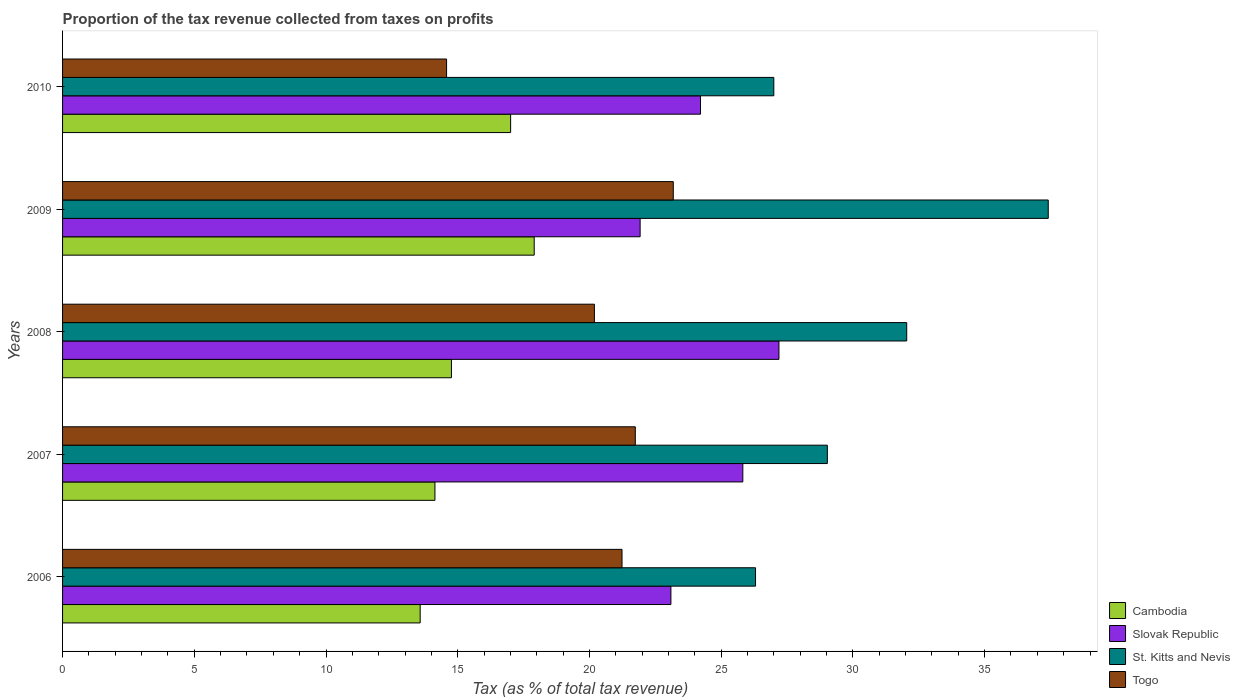How many groups of bars are there?
Your response must be concise. 5. Are the number of bars per tick equal to the number of legend labels?
Your answer should be compact. Yes. Are the number of bars on each tick of the Y-axis equal?
Make the answer very short. Yes. How many bars are there on the 5th tick from the top?
Your response must be concise. 4. How many bars are there on the 2nd tick from the bottom?
Ensure brevity in your answer.  4. In how many cases, is the number of bars for a given year not equal to the number of legend labels?
Make the answer very short. 0. What is the proportion of the tax revenue collected in Cambodia in 2007?
Give a very brief answer. 14.13. Across all years, what is the maximum proportion of the tax revenue collected in Cambodia?
Your response must be concise. 17.9. Across all years, what is the minimum proportion of the tax revenue collected in Togo?
Give a very brief answer. 14.58. In which year was the proportion of the tax revenue collected in Cambodia minimum?
Offer a very short reply. 2006. What is the total proportion of the tax revenue collected in Togo in the graph?
Your answer should be very brief. 100.92. What is the difference between the proportion of the tax revenue collected in Cambodia in 2007 and that in 2009?
Your answer should be compact. -3.77. What is the difference between the proportion of the tax revenue collected in Cambodia in 2010 and the proportion of the tax revenue collected in Slovak Republic in 2007?
Ensure brevity in your answer.  -8.81. What is the average proportion of the tax revenue collected in Togo per year?
Offer a very short reply. 20.18. In the year 2007, what is the difference between the proportion of the tax revenue collected in Cambodia and proportion of the tax revenue collected in Slovak Republic?
Give a very brief answer. -11.69. In how many years, is the proportion of the tax revenue collected in Slovak Republic greater than 22 %?
Provide a succinct answer. 4. What is the ratio of the proportion of the tax revenue collected in Cambodia in 2006 to that in 2008?
Your answer should be compact. 0.92. What is the difference between the highest and the second highest proportion of the tax revenue collected in Cambodia?
Your response must be concise. 0.9. What is the difference between the highest and the lowest proportion of the tax revenue collected in Slovak Republic?
Offer a terse response. 5.27. In how many years, is the proportion of the tax revenue collected in St. Kitts and Nevis greater than the average proportion of the tax revenue collected in St. Kitts and Nevis taken over all years?
Give a very brief answer. 2. Is the sum of the proportion of the tax revenue collected in St. Kitts and Nevis in 2007 and 2008 greater than the maximum proportion of the tax revenue collected in Togo across all years?
Provide a short and direct response. Yes. What does the 3rd bar from the top in 2006 represents?
Your response must be concise. Slovak Republic. What does the 2nd bar from the bottom in 2010 represents?
Give a very brief answer. Slovak Republic. Is it the case that in every year, the sum of the proportion of the tax revenue collected in Slovak Republic and proportion of the tax revenue collected in Togo is greater than the proportion of the tax revenue collected in Cambodia?
Offer a terse response. Yes. How many bars are there?
Ensure brevity in your answer.  20. Are all the bars in the graph horizontal?
Your answer should be compact. Yes. How many years are there in the graph?
Give a very brief answer. 5. Are the values on the major ticks of X-axis written in scientific E-notation?
Offer a terse response. No. Does the graph contain grids?
Offer a very short reply. No. How many legend labels are there?
Your answer should be very brief. 4. What is the title of the graph?
Your answer should be very brief. Proportion of the tax revenue collected from taxes on profits. What is the label or title of the X-axis?
Provide a short and direct response. Tax (as % of total tax revenue). What is the label or title of the Y-axis?
Offer a terse response. Years. What is the Tax (as % of total tax revenue) in Cambodia in 2006?
Your response must be concise. 13.57. What is the Tax (as % of total tax revenue) of Slovak Republic in 2006?
Your response must be concise. 23.09. What is the Tax (as % of total tax revenue) of St. Kitts and Nevis in 2006?
Offer a very short reply. 26.3. What is the Tax (as % of total tax revenue) in Togo in 2006?
Offer a terse response. 21.24. What is the Tax (as % of total tax revenue) in Cambodia in 2007?
Your response must be concise. 14.13. What is the Tax (as % of total tax revenue) of Slovak Republic in 2007?
Keep it short and to the point. 25.82. What is the Tax (as % of total tax revenue) in St. Kitts and Nevis in 2007?
Provide a short and direct response. 29.03. What is the Tax (as % of total tax revenue) in Togo in 2007?
Make the answer very short. 21.74. What is the Tax (as % of total tax revenue) in Cambodia in 2008?
Keep it short and to the point. 14.76. What is the Tax (as % of total tax revenue) in Slovak Republic in 2008?
Your response must be concise. 27.19. What is the Tax (as % of total tax revenue) of St. Kitts and Nevis in 2008?
Provide a succinct answer. 32.04. What is the Tax (as % of total tax revenue) of Togo in 2008?
Offer a very short reply. 20.19. What is the Tax (as % of total tax revenue) in Cambodia in 2009?
Your answer should be very brief. 17.9. What is the Tax (as % of total tax revenue) of Slovak Republic in 2009?
Offer a terse response. 21.92. What is the Tax (as % of total tax revenue) in St. Kitts and Nevis in 2009?
Your response must be concise. 37.41. What is the Tax (as % of total tax revenue) of Togo in 2009?
Your answer should be compact. 23.18. What is the Tax (as % of total tax revenue) in Cambodia in 2010?
Give a very brief answer. 17.01. What is the Tax (as % of total tax revenue) of Slovak Republic in 2010?
Provide a short and direct response. 24.21. What is the Tax (as % of total tax revenue) in St. Kitts and Nevis in 2010?
Provide a short and direct response. 27. What is the Tax (as % of total tax revenue) of Togo in 2010?
Your response must be concise. 14.58. Across all years, what is the maximum Tax (as % of total tax revenue) of Cambodia?
Ensure brevity in your answer.  17.9. Across all years, what is the maximum Tax (as % of total tax revenue) in Slovak Republic?
Give a very brief answer. 27.19. Across all years, what is the maximum Tax (as % of total tax revenue) in St. Kitts and Nevis?
Offer a very short reply. 37.41. Across all years, what is the maximum Tax (as % of total tax revenue) in Togo?
Offer a very short reply. 23.18. Across all years, what is the minimum Tax (as % of total tax revenue) in Cambodia?
Offer a terse response. 13.57. Across all years, what is the minimum Tax (as % of total tax revenue) of Slovak Republic?
Ensure brevity in your answer.  21.92. Across all years, what is the minimum Tax (as % of total tax revenue) in St. Kitts and Nevis?
Provide a succinct answer. 26.3. Across all years, what is the minimum Tax (as % of total tax revenue) of Togo?
Provide a succinct answer. 14.58. What is the total Tax (as % of total tax revenue) of Cambodia in the graph?
Provide a succinct answer. 77.38. What is the total Tax (as % of total tax revenue) of Slovak Republic in the graph?
Your response must be concise. 122.24. What is the total Tax (as % of total tax revenue) in St. Kitts and Nevis in the graph?
Give a very brief answer. 151.79. What is the total Tax (as % of total tax revenue) of Togo in the graph?
Give a very brief answer. 100.92. What is the difference between the Tax (as % of total tax revenue) of Cambodia in 2006 and that in 2007?
Offer a terse response. -0.56. What is the difference between the Tax (as % of total tax revenue) in Slovak Republic in 2006 and that in 2007?
Offer a terse response. -2.73. What is the difference between the Tax (as % of total tax revenue) of St. Kitts and Nevis in 2006 and that in 2007?
Give a very brief answer. -2.73. What is the difference between the Tax (as % of total tax revenue) in Togo in 2006 and that in 2007?
Ensure brevity in your answer.  -0.5. What is the difference between the Tax (as % of total tax revenue) of Cambodia in 2006 and that in 2008?
Make the answer very short. -1.19. What is the difference between the Tax (as % of total tax revenue) of Slovak Republic in 2006 and that in 2008?
Your answer should be compact. -4.1. What is the difference between the Tax (as % of total tax revenue) of St. Kitts and Nevis in 2006 and that in 2008?
Ensure brevity in your answer.  -5.74. What is the difference between the Tax (as % of total tax revenue) of Togo in 2006 and that in 2008?
Provide a succinct answer. 1.05. What is the difference between the Tax (as % of total tax revenue) of Cambodia in 2006 and that in 2009?
Provide a short and direct response. -4.33. What is the difference between the Tax (as % of total tax revenue) of Slovak Republic in 2006 and that in 2009?
Ensure brevity in your answer.  1.17. What is the difference between the Tax (as % of total tax revenue) of St. Kitts and Nevis in 2006 and that in 2009?
Make the answer very short. -11.11. What is the difference between the Tax (as % of total tax revenue) in Togo in 2006 and that in 2009?
Your response must be concise. -1.95. What is the difference between the Tax (as % of total tax revenue) in Cambodia in 2006 and that in 2010?
Provide a succinct answer. -3.43. What is the difference between the Tax (as % of total tax revenue) in Slovak Republic in 2006 and that in 2010?
Provide a short and direct response. -1.12. What is the difference between the Tax (as % of total tax revenue) in St. Kitts and Nevis in 2006 and that in 2010?
Your answer should be compact. -0.69. What is the difference between the Tax (as % of total tax revenue) in Togo in 2006 and that in 2010?
Offer a terse response. 6.66. What is the difference between the Tax (as % of total tax revenue) of Cambodia in 2007 and that in 2008?
Your answer should be very brief. -0.63. What is the difference between the Tax (as % of total tax revenue) of Slovak Republic in 2007 and that in 2008?
Your answer should be very brief. -1.37. What is the difference between the Tax (as % of total tax revenue) in St. Kitts and Nevis in 2007 and that in 2008?
Provide a short and direct response. -3.01. What is the difference between the Tax (as % of total tax revenue) in Togo in 2007 and that in 2008?
Ensure brevity in your answer.  1.55. What is the difference between the Tax (as % of total tax revenue) in Cambodia in 2007 and that in 2009?
Offer a very short reply. -3.77. What is the difference between the Tax (as % of total tax revenue) of Slovak Republic in 2007 and that in 2009?
Ensure brevity in your answer.  3.9. What is the difference between the Tax (as % of total tax revenue) in St. Kitts and Nevis in 2007 and that in 2009?
Your response must be concise. -8.39. What is the difference between the Tax (as % of total tax revenue) of Togo in 2007 and that in 2009?
Keep it short and to the point. -1.44. What is the difference between the Tax (as % of total tax revenue) in Cambodia in 2007 and that in 2010?
Keep it short and to the point. -2.87. What is the difference between the Tax (as % of total tax revenue) of Slovak Republic in 2007 and that in 2010?
Your answer should be compact. 1.61. What is the difference between the Tax (as % of total tax revenue) of St. Kitts and Nevis in 2007 and that in 2010?
Make the answer very short. 2.03. What is the difference between the Tax (as % of total tax revenue) of Togo in 2007 and that in 2010?
Offer a very short reply. 7.16. What is the difference between the Tax (as % of total tax revenue) of Cambodia in 2008 and that in 2009?
Provide a succinct answer. -3.14. What is the difference between the Tax (as % of total tax revenue) of Slovak Republic in 2008 and that in 2009?
Provide a succinct answer. 5.27. What is the difference between the Tax (as % of total tax revenue) in St. Kitts and Nevis in 2008 and that in 2009?
Provide a succinct answer. -5.37. What is the difference between the Tax (as % of total tax revenue) of Togo in 2008 and that in 2009?
Your answer should be very brief. -2.99. What is the difference between the Tax (as % of total tax revenue) of Cambodia in 2008 and that in 2010?
Keep it short and to the point. -2.25. What is the difference between the Tax (as % of total tax revenue) of Slovak Republic in 2008 and that in 2010?
Give a very brief answer. 2.98. What is the difference between the Tax (as % of total tax revenue) of St. Kitts and Nevis in 2008 and that in 2010?
Keep it short and to the point. 5.04. What is the difference between the Tax (as % of total tax revenue) of Togo in 2008 and that in 2010?
Provide a short and direct response. 5.61. What is the difference between the Tax (as % of total tax revenue) in Cambodia in 2009 and that in 2010?
Provide a short and direct response. 0.9. What is the difference between the Tax (as % of total tax revenue) in Slovak Republic in 2009 and that in 2010?
Provide a short and direct response. -2.29. What is the difference between the Tax (as % of total tax revenue) of St. Kitts and Nevis in 2009 and that in 2010?
Your answer should be very brief. 10.42. What is the difference between the Tax (as % of total tax revenue) in Togo in 2009 and that in 2010?
Offer a terse response. 8.61. What is the difference between the Tax (as % of total tax revenue) of Cambodia in 2006 and the Tax (as % of total tax revenue) of Slovak Republic in 2007?
Ensure brevity in your answer.  -12.25. What is the difference between the Tax (as % of total tax revenue) of Cambodia in 2006 and the Tax (as % of total tax revenue) of St. Kitts and Nevis in 2007?
Give a very brief answer. -15.46. What is the difference between the Tax (as % of total tax revenue) of Cambodia in 2006 and the Tax (as % of total tax revenue) of Togo in 2007?
Make the answer very short. -8.17. What is the difference between the Tax (as % of total tax revenue) of Slovak Republic in 2006 and the Tax (as % of total tax revenue) of St. Kitts and Nevis in 2007?
Ensure brevity in your answer.  -5.94. What is the difference between the Tax (as % of total tax revenue) of Slovak Republic in 2006 and the Tax (as % of total tax revenue) of Togo in 2007?
Offer a terse response. 1.35. What is the difference between the Tax (as % of total tax revenue) in St. Kitts and Nevis in 2006 and the Tax (as % of total tax revenue) in Togo in 2007?
Offer a terse response. 4.56. What is the difference between the Tax (as % of total tax revenue) of Cambodia in 2006 and the Tax (as % of total tax revenue) of Slovak Republic in 2008?
Ensure brevity in your answer.  -13.62. What is the difference between the Tax (as % of total tax revenue) of Cambodia in 2006 and the Tax (as % of total tax revenue) of St. Kitts and Nevis in 2008?
Your answer should be compact. -18.47. What is the difference between the Tax (as % of total tax revenue) of Cambodia in 2006 and the Tax (as % of total tax revenue) of Togo in 2008?
Your response must be concise. -6.61. What is the difference between the Tax (as % of total tax revenue) of Slovak Republic in 2006 and the Tax (as % of total tax revenue) of St. Kitts and Nevis in 2008?
Your answer should be very brief. -8.95. What is the difference between the Tax (as % of total tax revenue) in Slovak Republic in 2006 and the Tax (as % of total tax revenue) in Togo in 2008?
Offer a very short reply. 2.9. What is the difference between the Tax (as % of total tax revenue) of St. Kitts and Nevis in 2006 and the Tax (as % of total tax revenue) of Togo in 2008?
Your answer should be very brief. 6.12. What is the difference between the Tax (as % of total tax revenue) in Cambodia in 2006 and the Tax (as % of total tax revenue) in Slovak Republic in 2009?
Your answer should be very brief. -8.35. What is the difference between the Tax (as % of total tax revenue) of Cambodia in 2006 and the Tax (as % of total tax revenue) of St. Kitts and Nevis in 2009?
Make the answer very short. -23.84. What is the difference between the Tax (as % of total tax revenue) of Cambodia in 2006 and the Tax (as % of total tax revenue) of Togo in 2009?
Give a very brief answer. -9.61. What is the difference between the Tax (as % of total tax revenue) in Slovak Republic in 2006 and the Tax (as % of total tax revenue) in St. Kitts and Nevis in 2009?
Make the answer very short. -14.32. What is the difference between the Tax (as % of total tax revenue) of Slovak Republic in 2006 and the Tax (as % of total tax revenue) of Togo in 2009?
Offer a very short reply. -0.09. What is the difference between the Tax (as % of total tax revenue) in St. Kitts and Nevis in 2006 and the Tax (as % of total tax revenue) in Togo in 2009?
Provide a short and direct response. 3.12. What is the difference between the Tax (as % of total tax revenue) of Cambodia in 2006 and the Tax (as % of total tax revenue) of Slovak Republic in 2010?
Your answer should be very brief. -10.64. What is the difference between the Tax (as % of total tax revenue) in Cambodia in 2006 and the Tax (as % of total tax revenue) in St. Kitts and Nevis in 2010?
Make the answer very short. -13.42. What is the difference between the Tax (as % of total tax revenue) in Cambodia in 2006 and the Tax (as % of total tax revenue) in Togo in 2010?
Your answer should be very brief. -1. What is the difference between the Tax (as % of total tax revenue) in Slovak Republic in 2006 and the Tax (as % of total tax revenue) in St. Kitts and Nevis in 2010?
Provide a short and direct response. -3.91. What is the difference between the Tax (as % of total tax revenue) in Slovak Republic in 2006 and the Tax (as % of total tax revenue) in Togo in 2010?
Ensure brevity in your answer.  8.52. What is the difference between the Tax (as % of total tax revenue) in St. Kitts and Nevis in 2006 and the Tax (as % of total tax revenue) in Togo in 2010?
Your answer should be compact. 11.73. What is the difference between the Tax (as % of total tax revenue) in Cambodia in 2007 and the Tax (as % of total tax revenue) in Slovak Republic in 2008?
Keep it short and to the point. -13.06. What is the difference between the Tax (as % of total tax revenue) of Cambodia in 2007 and the Tax (as % of total tax revenue) of St. Kitts and Nevis in 2008?
Offer a terse response. -17.91. What is the difference between the Tax (as % of total tax revenue) of Cambodia in 2007 and the Tax (as % of total tax revenue) of Togo in 2008?
Offer a very short reply. -6.05. What is the difference between the Tax (as % of total tax revenue) of Slovak Republic in 2007 and the Tax (as % of total tax revenue) of St. Kitts and Nevis in 2008?
Keep it short and to the point. -6.22. What is the difference between the Tax (as % of total tax revenue) in Slovak Republic in 2007 and the Tax (as % of total tax revenue) in Togo in 2008?
Give a very brief answer. 5.63. What is the difference between the Tax (as % of total tax revenue) of St. Kitts and Nevis in 2007 and the Tax (as % of total tax revenue) of Togo in 2008?
Your answer should be very brief. 8.84. What is the difference between the Tax (as % of total tax revenue) in Cambodia in 2007 and the Tax (as % of total tax revenue) in Slovak Republic in 2009?
Provide a succinct answer. -7.79. What is the difference between the Tax (as % of total tax revenue) of Cambodia in 2007 and the Tax (as % of total tax revenue) of St. Kitts and Nevis in 2009?
Your response must be concise. -23.28. What is the difference between the Tax (as % of total tax revenue) of Cambodia in 2007 and the Tax (as % of total tax revenue) of Togo in 2009?
Keep it short and to the point. -9.05. What is the difference between the Tax (as % of total tax revenue) in Slovak Republic in 2007 and the Tax (as % of total tax revenue) in St. Kitts and Nevis in 2009?
Make the answer very short. -11.59. What is the difference between the Tax (as % of total tax revenue) in Slovak Republic in 2007 and the Tax (as % of total tax revenue) in Togo in 2009?
Ensure brevity in your answer.  2.64. What is the difference between the Tax (as % of total tax revenue) of St. Kitts and Nevis in 2007 and the Tax (as % of total tax revenue) of Togo in 2009?
Provide a short and direct response. 5.85. What is the difference between the Tax (as % of total tax revenue) in Cambodia in 2007 and the Tax (as % of total tax revenue) in Slovak Republic in 2010?
Keep it short and to the point. -10.08. What is the difference between the Tax (as % of total tax revenue) in Cambodia in 2007 and the Tax (as % of total tax revenue) in St. Kitts and Nevis in 2010?
Offer a very short reply. -12.86. What is the difference between the Tax (as % of total tax revenue) in Cambodia in 2007 and the Tax (as % of total tax revenue) in Togo in 2010?
Make the answer very short. -0.44. What is the difference between the Tax (as % of total tax revenue) in Slovak Republic in 2007 and the Tax (as % of total tax revenue) in St. Kitts and Nevis in 2010?
Provide a succinct answer. -1.18. What is the difference between the Tax (as % of total tax revenue) in Slovak Republic in 2007 and the Tax (as % of total tax revenue) in Togo in 2010?
Keep it short and to the point. 11.25. What is the difference between the Tax (as % of total tax revenue) of St. Kitts and Nevis in 2007 and the Tax (as % of total tax revenue) of Togo in 2010?
Keep it short and to the point. 14.45. What is the difference between the Tax (as % of total tax revenue) in Cambodia in 2008 and the Tax (as % of total tax revenue) in Slovak Republic in 2009?
Make the answer very short. -7.16. What is the difference between the Tax (as % of total tax revenue) of Cambodia in 2008 and the Tax (as % of total tax revenue) of St. Kitts and Nevis in 2009?
Provide a short and direct response. -22.65. What is the difference between the Tax (as % of total tax revenue) in Cambodia in 2008 and the Tax (as % of total tax revenue) in Togo in 2009?
Provide a succinct answer. -8.42. What is the difference between the Tax (as % of total tax revenue) of Slovak Republic in 2008 and the Tax (as % of total tax revenue) of St. Kitts and Nevis in 2009?
Make the answer very short. -10.22. What is the difference between the Tax (as % of total tax revenue) of Slovak Republic in 2008 and the Tax (as % of total tax revenue) of Togo in 2009?
Your answer should be very brief. 4.01. What is the difference between the Tax (as % of total tax revenue) in St. Kitts and Nevis in 2008 and the Tax (as % of total tax revenue) in Togo in 2009?
Your response must be concise. 8.86. What is the difference between the Tax (as % of total tax revenue) of Cambodia in 2008 and the Tax (as % of total tax revenue) of Slovak Republic in 2010?
Offer a terse response. -9.45. What is the difference between the Tax (as % of total tax revenue) in Cambodia in 2008 and the Tax (as % of total tax revenue) in St. Kitts and Nevis in 2010?
Provide a succinct answer. -12.24. What is the difference between the Tax (as % of total tax revenue) of Cambodia in 2008 and the Tax (as % of total tax revenue) of Togo in 2010?
Make the answer very short. 0.18. What is the difference between the Tax (as % of total tax revenue) of Slovak Republic in 2008 and the Tax (as % of total tax revenue) of St. Kitts and Nevis in 2010?
Make the answer very short. 0.2. What is the difference between the Tax (as % of total tax revenue) of Slovak Republic in 2008 and the Tax (as % of total tax revenue) of Togo in 2010?
Provide a short and direct response. 12.62. What is the difference between the Tax (as % of total tax revenue) of St. Kitts and Nevis in 2008 and the Tax (as % of total tax revenue) of Togo in 2010?
Offer a terse response. 17.47. What is the difference between the Tax (as % of total tax revenue) of Cambodia in 2009 and the Tax (as % of total tax revenue) of Slovak Republic in 2010?
Make the answer very short. -6.31. What is the difference between the Tax (as % of total tax revenue) in Cambodia in 2009 and the Tax (as % of total tax revenue) in St. Kitts and Nevis in 2010?
Offer a very short reply. -9.09. What is the difference between the Tax (as % of total tax revenue) in Cambodia in 2009 and the Tax (as % of total tax revenue) in Togo in 2010?
Offer a very short reply. 3.33. What is the difference between the Tax (as % of total tax revenue) in Slovak Republic in 2009 and the Tax (as % of total tax revenue) in St. Kitts and Nevis in 2010?
Give a very brief answer. -5.07. What is the difference between the Tax (as % of total tax revenue) in Slovak Republic in 2009 and the Tax (as % of total tax revenue) in Togo in 2010?
Your response must be concise. 7.35. What is the difference between the Tax (as % of total tax revenue) of St. Kitts and Nevis in 2009 and the Tax (as % of total tax revenue) of Togo in 2010?
Ensure brevity in your answer.  22.84. What is the average Tax (as % of total tax revenue) of Cambodia per year?
Keep it short and to the point. 15.48. What is the average Tax (as % of total tax revenue) of Slovak Republic per year?
Your response must be concise. 24.45. What is the average Tax (as % of total tax revenue) in St. Kitts and Nevis per year?
Provide a short and direct response. 30.36. What is the average Tax (as % of total tax revenue) of Togo per year?
Your answer should be compact. 20.18. In the year 2006, what is the difference between the Tax (as % of total tax revenue) in Cambodia and Tax (as % of total tax revenue) in Slovak Republic?
Your response must be concise. -9.52. In the year 2006, what is the difference between the Tax (as % of total tax revenue) in Cambodia and Tax (as % of total tax revenue) in St. Kitts and Nevis?
Offer a terse response. -12.73. In the year 2006, what is the difference between the Tax (as % of total tax revenue) in Cambodia and Tax (as % of total tax revenue) in Togo?
Make the answer very short. -7.66. In the year 2006, what is the difference between the Tax (as % of total tax revenue) in Slovak Republic and Tax (as % of total tax revenue) in St. Kitts and Nevis?
Offer a terse response. -3.21. In the year 2006, what is the difference between the Tax (as % of total tax revenue) of Slovak Republic and Tax (as % of total tax revenue) of Togo?
Make the answer very short. 1.86. In the year 2006, what is the difference between the Tax (as % of total tax revenue) in St. Kitts and Nevis and Tax (as % of total tax revenue) in Togo?
Keep it short and to the point. 5.07. In the year 2007, what is the difference between the Tax (as % of total tax revenue) in Cambodia and Tax (as % of total tax revenue) in Slovak Republic?
Offer a terse response. -11.69. In the year 2007, what is the difference between the Tax (as % of total tax revenue) of Cambodia and Tax (as % of total tax revenue) of St. Kitts and Nevis?
Make the answer very short. -14.89. In the year 2007, what is the difference between the Tax (as % of total tax revenue) in Cambodia and Tax (as % of total tax revenue) in Togo?
Ensure brevity in your answer.  -7.61. In the year 2007, what is the difference between the Tax (as % of total tax revenue) in Slovak Republic and Tax (as % of total tax revenue) in St. Kitts and Nevis?
Give a very brief answer. -3.21. In the year 2007, what is the difference between the Tax (as % of total tax revenue) in Slovak Republic and Tax (as % of total tax revenue) in Togo?
Give a very brief answer. 4.08. In the year 2007, what is the difference between the Tax (as % of total tax revenue) of St. Kitts and Nevis and Tax (as % of total tax revenue) of Togo?
Offer a terse response. 7.29. In the year 2008, what is the difference between the Tax (as % of total tax revenue) of Cambodia and Tax (as % of total tax revenue) of Slovak Republic?
Your answer should be compact. -12.43. In the year 2008, what is the difference between the Tax (as % of total tax revenue) of Cambodia and Tax (as % of total tax revenue) of St. Kitts and Nevis?
Offer a very short reply. -17.28. In the year 2008, what is the difference between the Tax (as % of total tax revenue) of Cambodia and Tax (as % of total tax revenue) of Togo?
Keep it short and to the point. -5.43. In the year 2008, what is the difference between the Tax (as % of total tax revenue) of Slovak Republic and Tax (as % of total tax revenue) of St. Kitts and Nevis?
Your answer should be very brief. -4.85. In the year 2008, what is the difference between the Tax (as % of total tax revenue) in Slovak Republic and Tax (as % of total tax revenue) in Togo?
Make the answer very short. 7.01. In the year 2008, what is the difference between the Tax (as % of total tax revenue) of St. Kitts and Nevis and Tax (as % of total tax revenue) of Togo?
Your answer should be compact. 11.85. In the year 2009, what is the difference between the Tax (as % of total tax revenue) of Cambodia and Tax (as % of total tax revenue) of Slovak Republic?
Ensure brevity in your answer.  -4.02. In the year 2009, what is the difference between the Tax (as % of total tax revenue) in Cambodia and Tax (as % of total tax revenue) in St. Kitts and Nevis?
Give a very brief answer. -19.51. In the year 2009, what is the difference between the Tax (as % of total tax revenue) in Cambodia and Tax (as % of total tax revenue) in Togo?
Your answer should be very brief. -5.28. In the year 2009, what is the difference between the Tax (as % of total tax revenue) in Slovak Republic and Tax (as % of total tax revenue) in St. Kitts and Nevis?
Offer a terse response. -15.49. In the year 2009, what is the difference between the Tax (as % of total tax revenue) in Slovak Republic and Tax (as % of total tax revenue) in Togo?
Give a very brief answer. -1.26. In the year 2009, what is the difference between the Tax (as % of total tax revenue) in St. Kitts and Nevis and Tax (as % of total tax revenue) in Togo?
Provide a short and direct response. 14.23. In the year 2010, what is the difference between the Tax (as % of total tax revenue) in Cambodia and Tax (as % of total tax revenue) in Slovak Republic?
Your answer should be very brief. -7.21. In the year 2010, what is the difference between the Tax (as % of total tax revenue) of Cambodia and Tax (as % of total tax revenue) of St. Kitts and Nevis?
Offer a very short reply. -9.99. In the year 2010, what is the difference between the Tax (as % of total tax revenue) in Cambodia and Tax (as % of total tax revenue) in Togo?
Ensure brevity in your answer.  2.43. In the year 2010, what is the difference between the Tax (as % of total tax revenue) of Slovak Republic and Tax (as % of total tax revenue) of St. Kitts and Nevis?
Provide a succinct answer. -2.78. In the year 2010, what is the difference between the Tax (as % of total tax revenue) of Slovak Republic and Tax (as % of total tax revenue) of Togo?
Provide a succinct answer. 9.64. In the year 2010, what is the difference between the Tax (as % of total tax revenue) in St. Kitts and Nevis and Tax (as % of total tax revenue) in Togo?
Your response must be concise. 12.42. What is the ratio of the Tax (as % of total tax revenue) of Cambodia in 2006 to that in 2007?
Give a very brief answer. 0.96. What is the ratio of the Tax (as % of total tax revenue) in Slovak Republic in 2006 to that in 2007?
Keep it short and to the point. 0.89. What is the ratio of the Tax (as % of total tax revenue) in St. Kitts and Nevis in 2006 to that in 2007?
Make the answer very short. 0.91. What is the ratio of the Tax (as % of total tax revenue) of Togo in 2006 to that in 2007?
Your answer should be very brief. 0.98. What is the ratio of the Tax (as % of total tax revenue) in Cambodia in 2006 to that in 2008?
Ensure brevity in your answer.  0.92. What is the ratio of the Tax (as % of total tax revenue) of Slovak Republic in 2006 to that in 2008?
Ensure brevity in your answer.  0.85. What is the ratio of the Tax (as % of total tax revenue) in St. Kitts and Nevis in 2006 to that in 2008?
Offer a terse response. 0.82. What is the ratio of the Tax (as % of total tax revenue) of Togo in 2006 to that in 2008?
Ensure brevity in your answer.  1.05. What is the ratio of the Tax (as % of total tax revenue) in Cambodia in 2006 to that in 2009?
Offer a very short reply. 0.76. What is the ratio of the Tax (as % of total tax revenue) of Slovak Republic in 2006 to that in 2009?
Your answer should be compact. 1.05. What is the ratio of the Tax (as % of total tax revenue) of St. Kitts and Nevis in 2006 to that in 2009?
Keep it short and to the point. 0.7. What is the ratio of the Tax (as % of total tax revenue) of Togo in 2006 to that in 2009?
Your answer should be compact. 0.92. What is the ratio of the Tax (as % of total tax revenue) in Cambodia in 2006 to that in 2010?
Give a very brief answer. 0.8. What is the ratio of the Tax (as % of total tax revenue) in Slovak Republic in 2006 to that in 2010?
Give a very brief answer. 0.95. What is the ratio of the Tax (as % of total tax revenue) in St. Kitts and Nevis in 2006 to that in 2010?
Provide a short and direct response. 0.97. What is the ratio of the Tax (as % of total tax revenue) in Togo in 2006 to that in 2010?
Provide a succinct answer. 1.46. What is the ratio of the Tax (as % of total tax revenue) of Cambodia in 2007 to that in 2008?
Keep it short and to the point. 0.96. What is the ratio of the Tax (as % of total tax revenue) of Slovak Republic in 2007 to that in 2008?
Ensure brevity in your answer.  0.95. What is the ratio of the Tax (as % of total tax revenue) of St. Kitts and Nevis in 2007 to that in 2008?
Keep it short and to the point. 0.91. What is the ratio of the Tax (as % of total tax revenue) of Togo in 2007 to that in 2008?
Ensure brevity in your answer.  1.08. What is the ratio of the Tax (as % of total tax revenue) of Cambodia in 2007 to that in 2009?
Provide a short and direct response. 0.79. What is the ratio of the Tax (as % of total tax revenue) in Slovak Republic in 2007 to that in 2009?
Your response must be concise. 1.18. What is the ratio of the Tax (as % of total tax revenue) in St. Kitts and Nevis in 2007 to that in 2009?
Make the answer very short. 0.78. What is the ratio of the Tax (as % of total tax revenue) of Togo in 2007 to that in 2009?
Your answer should be compact. 0.94. What is the ratio of the Tax (as % of total tax revenue) of Cambodia in 2007 to that in 2010?
Offer a very short reply. 0.83. What is the ratio of the Tax (as % of total tax revenue) of Slovak Republic in 2007 to that in 2010?
Your answer should be compact. 1.07. What is the ratio of the Tax (as % of total tax revenue) in St. Kitts and Nevis in 2007 to that in 2010?
Ensure brevity in your answer.  1.08. What is the ratio of the Tax (as % of total tax revenue) in Togo in 2007 to that in 2010?
Your answer should be compact. 1.49. What is the ratio of the Tax (as % of total tax revenue) of Cambodia in 2008 to that in 2009?
Provide a short and direct response. 0.82. What is the ratio of the Tax (as % of total tax revenue) in Slovak Republic in 2008 to that in 2009?
Offer a very short reply. 1.24. What is the ratio of the Tax (as % of total tax revenue) in St. Kitts and Nevis in 2008 to that in 2009?
Offer a terse response. 0.86. What is the ratio of the Tax (as % of total tax revenue) of Togo in 2008 to that in 2009?
Offer a very short reply. 0.87. What is the ratio of the Tax (as % of total tax revenue) of Cambodia in 2008 to that in 2010?
Keep it short and to the point. 0.87. What is the ratio of the Tax (as % of total tax revenue) of Slovak Republic in 2008 to that in 2010?
Your answer should be very brief. 1.12. What is the ratio of the Tax (as % of total tax revenue) of St. Kitts and Nevis in 2008 to that in 2010?
Your response must be concise. 1.19. What is the ratio of the Tax (as % of total tax revenue) of Togo in 2008 to that in 2010?
Your answer should be compact. 1.38. What is the ratio of the Tax (as % of total tax revenue) of Cambodia in 2009 to that in 2010?
Your answer should be compact. 1.05. What is the ratio of the Tax (as % of total tax revenue) in Slovak Republic in 2009 to that in 2010?
Ensure brevity in your answer.  0.91. What is the ratio of the Tax (as % of total tax revenue) of St. Kitts and Nevis in 2009 to that in 2010?
Keep it short and to the point. 1.39. What is the ratio of the Tax (as % of total tax revenue) in Togo in 2009 to that in 2010?
Your response must be concise. 1.59. What is the difference between the highest and the second highest Tax (as % of total tax revenue) of Cambodia?
Offer a very short reply. 0.9. What is the difference between the highest and the second highest Tax (as % of total tax revenue) of Slovak Republic?
Your answer should be very brief. 1.37. What is the difference between the highest and the second highest Tax (as % of total tax revenue) in St. Kitts and Nevis?
Provide a short and direct response. 5.37. What is the difference between the highest and the second highest Tax (as % of total tax revenue) of Togo?
Offer a terse response. 1.44. What is the difference between the highest and the lowest Tax (as % of total tax revenue) of Cambodia?
Provide a short and direct response. 4.33. What is the difference between the highest and the lowest Tax (as % of total tax revenue) in Slovak Republic?
Your answer should be compact. 5.27. What is the difference between the highest and the lowest Tax (as % of total tax revenue) in St. Kitts and Nevis?
Offer a terse response. 11.11. What is the difference between the highest and the lowest Tax (as % of total tax revenue) of Togo?
Keep it short and to the point. 8.61. 